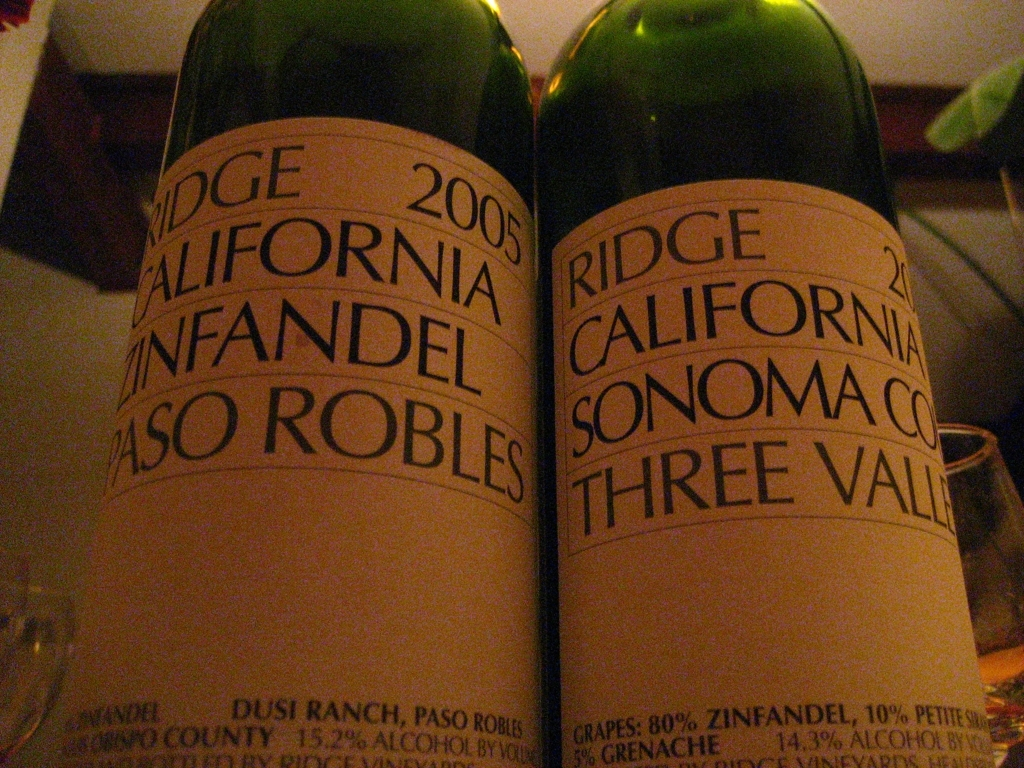What can you tell me about the labels on these bottles? The image features two bottles of Ridge wine, one is a 2005 Paso Robles Zinfandel from Dusi Ranch, San Luis Obispo County with 15.2% alcohol by volume, and the other is a 2005 Sonoma County Three Valleys with 80% Zinfandel, 10% Petite Sirah, and 10% Grenache with 14.3% alcohol by volume. The labels suggest these are products of California vineyards, known for producing quality wines, demonstrating a blend of different grape types and regions. Could you guess the occasion for these wines? Given the prominence of the wine bottles and the blurred background, it's possible these wines were selected for a special occasion such as a dinner party, tasting event, or a gift. These particular vintages from Ridge are likely to be appreciated by connoisseurs, suggesting that the setting is one where the wine's quality and character are being celebrated. 